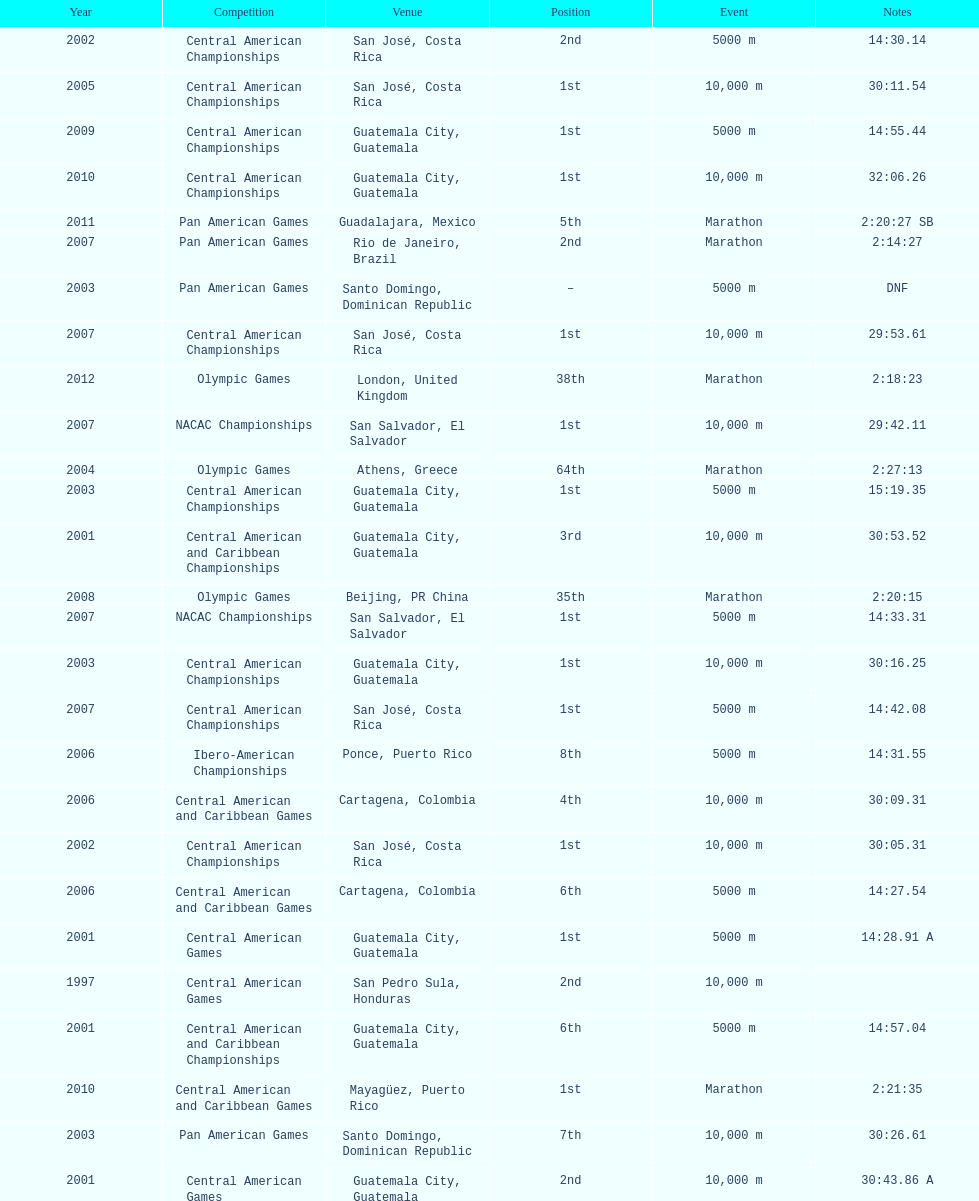What was the first competition this competitor competed in? Central American Games. 